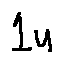<formula> <loc_0><loc_0><loc_500><loc_500>1 u</formula> 